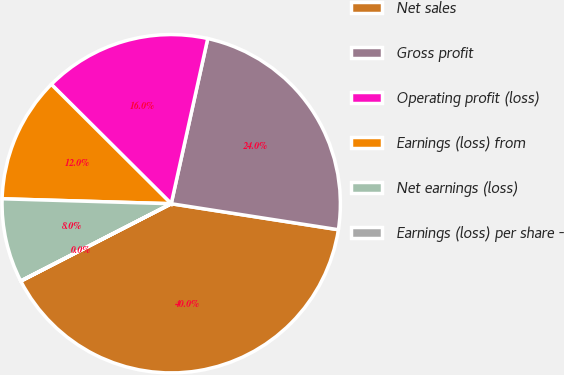Convert chart. <chart><loc_0><loc_0><loc_500><loc_500><pie_chart><fcel>Net sales<fcel>Gross profit<fcel>Operating profit (loss)<fcel>Earnings (loss) from<fcel>Net earnings (loss)<fcel>Earnings (loss) per share -<nl><fcel>39.98%<fcel>23.99%<fcel>16.0%<fcel>12.0%<fcel>8.01%<fcel>0.02%<nl></chart> 